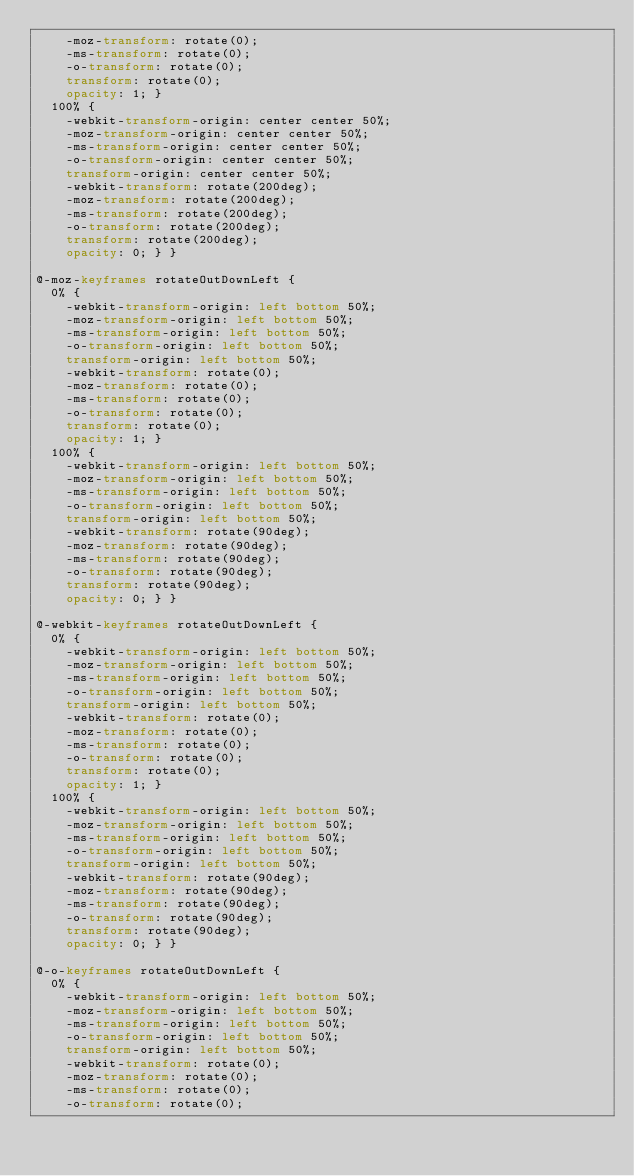Convert code to text. <code><loc_0><loc_0><loc_500><loc_500><_CSS_>    -moz-transform: rotate(0);
    -ms-transform: rotate(0);
    -o-transform: rotate(0);
    transform: rotate(0);
    opacity: 1; }
  100% {
    -webkit-transform-origin: center center 50%;
    -moz-transform-origin: center center 50%;
    -ms-transform-origin: center center 50%;
    -o-transform-origin: center center 50%;
    transform-origin: center center 50%;
    -webkit-transform: rotate(200deg);
    -moz-transform: rotate(200deg);
    -ms-transform: rotate(200deg);
    -o-transform: rotate(200deg);
    transform: rotate(200deg);
    opacity: 0; } }

@-moz-keyframes rotateOutDownLeft {
  0% {
    -webkit-transform-origin: left bottom 50%;
    -moz-transform-origin: left bottom 50%;
    -ms-transform-origin: left bottom 50%;
    -o-transform-origin: left bottom 50%;
    transform-origin: left bottom 50%;
    -webkit-transform: rotate(0);
    -moz-transform: rotate(0);
    -ms-transform: rotate(0);
    -o-transform: rotate(0);
    transform: rotate(0);
    opacity: 1; }
  100% {
    -webkit-transform-origin: left bottom 50%;
    -moz-transform-origin: left bottom 50%;
    -ms-transform-origin: left bottom 50%;
    -o-transform-origin: left bottom 50%;
    transform-origin: left bottom 50%;
    -webkit-transform: rotate(90deg);
    -moz-transform: rotate(90deg);
    -ms-transform: rotate(90deg);
    -o-transform: rotate(90deg);
    transform: rotate(90deg);
    opacity: 0; } }

@-webkit-keyframes rotateOutDownLeft {
  0% {
    -webkit-transform-origin: left bottom 50%;
    -moz-transform-origin: left bottom 50%;
    -ms-transform-origin: left bottom 50%;
    -o-transform-origin: left bottom 50%;
    transform-origin: left bottom 50%;
    -webkit-transform: rotate(0);
    -moz-transform: rotate(0);
    -ms-transform: rotate(0);
    -o-transform: rotate(0);
    transform: rotate(0);
    opacity: 1; }
  100% {
    -webkit-transform-origin: left bottom 50%;
    -moz-transform-origin: left bottom 50%;
    -ms-transform-origin: left bottom 50%;
    -o-transform-origin: left bottom 50%;
    transform-origin: left bottom 50%;
    -webkit-transform: rotate(90deg);
    -moz-transform: rotate(90deg);
    -ms-transform: rotate(90deg);
    -o-transform: rotate(90deg);
    transform: rotate(90deg);
    opacity: 0; } }

@-o-keyframes rotateOutDownLeft {
  0% {
    -webkit-transform-origin: left bottom 50%;
    -moz-transform-origin: left bottom 50%;
    -ms-transform-origin: left bottom 50%;
    -o-transform-origin: left bottom 50%;
    transform-origin: left bottom 50%;
    -webkit-transform: rotate(0);
    -moz-transform: rotate(0);
    -ms-transform: rotate(0);
    -o-transform: rotate(0);</code> 